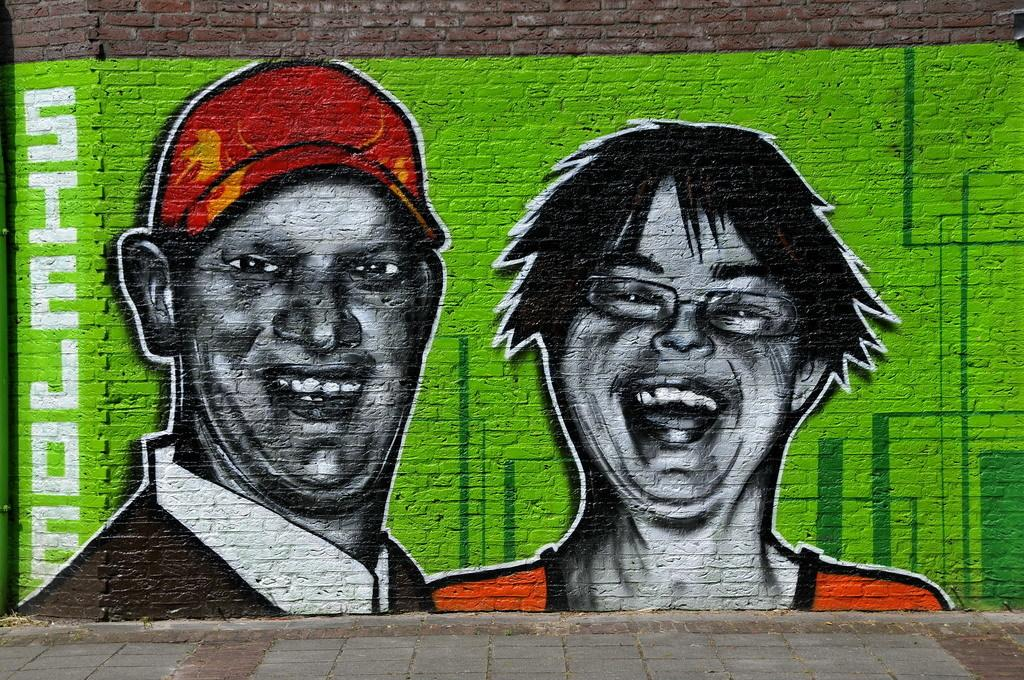What is present on the wall in the image? There is a painting on the wall in the image. What does the painting depict? The painting depicts two persons. Can you describe the individuals in the painting? One person in the painting is a man on the left side, and the other person is a girl on the right side. What type of glove can be seen in the painting? There is no glove present in the painting; it depicts two persons without any accessories. 